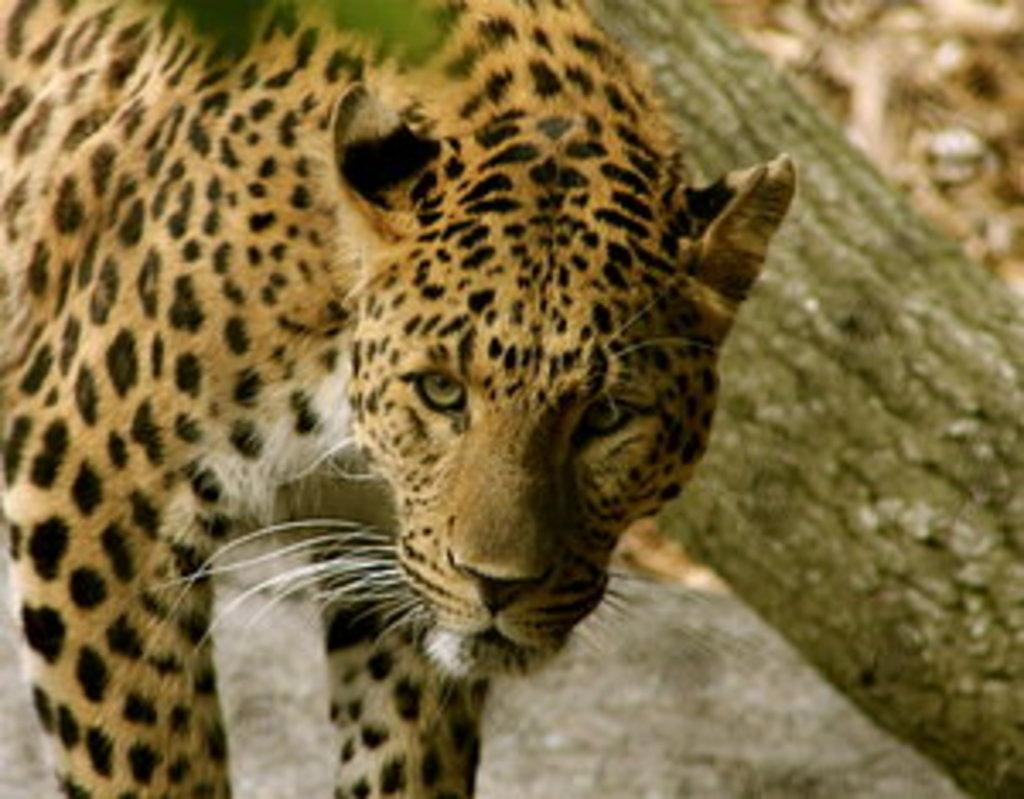What animal is the main subject of the image? There is a cheetah in the image. Can you describe the color pattern of the cheetah? The cheetah is yellow and black in color. What is the cheetah doing in the image? The cheetah is standing. What can be seen on the right side of the image? There is a tree trunk on the right side of the image. What type of ink is being used to write on the street in the image? There is no ink or writing on the street in the image; it only features a cheetah and a tree trunk. 